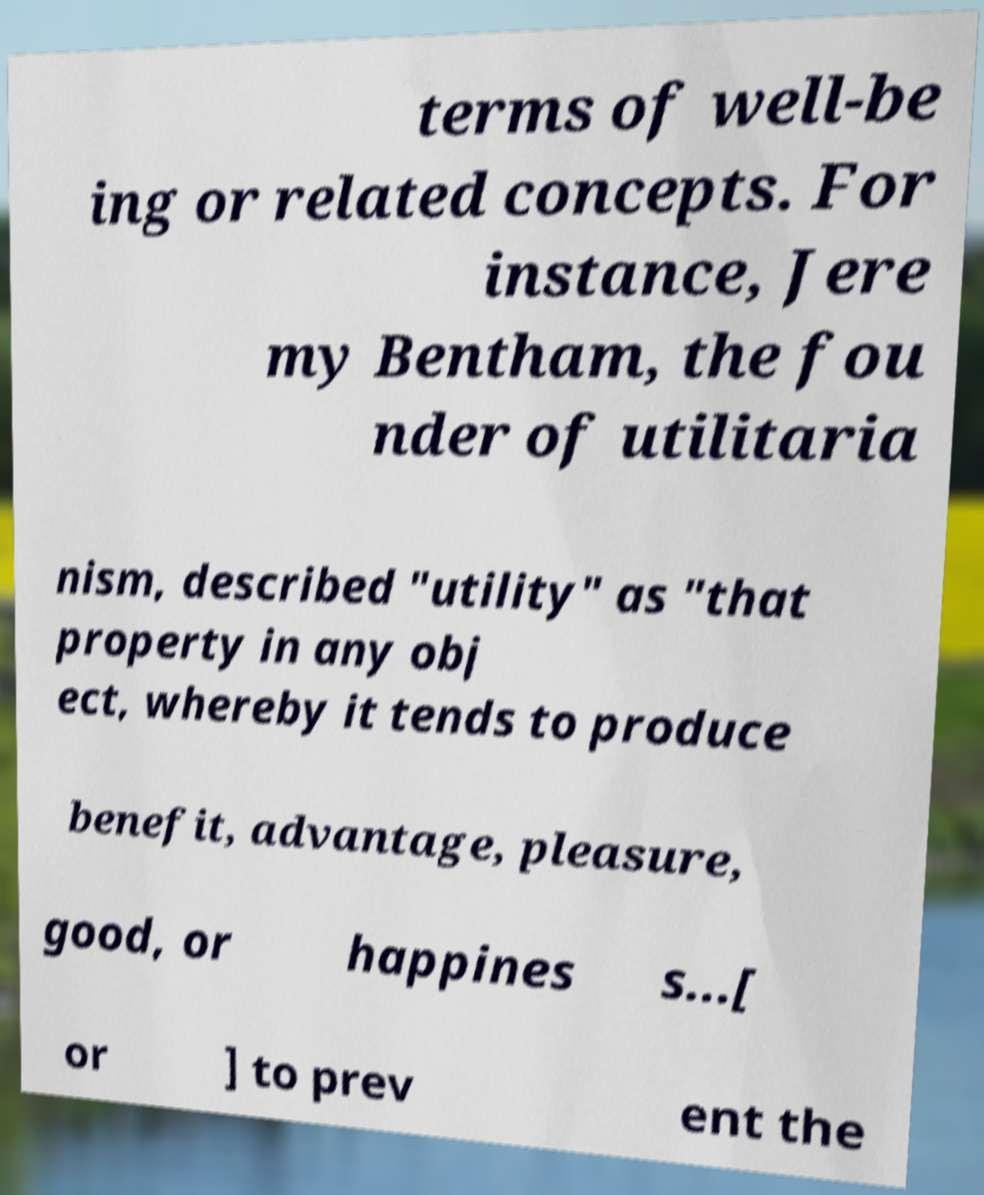Could you assist in decoding the text presented in this image and type it out clearly? terms of well-be ing or related concepts. For instance, Jere my Bentham, the fou nder of utilitaria nism, described "utility" as "that property in any obj ect, whereby it tends to produce benefit, advantage, pleasure, good, or happines s...[ or ] to prev ent the 